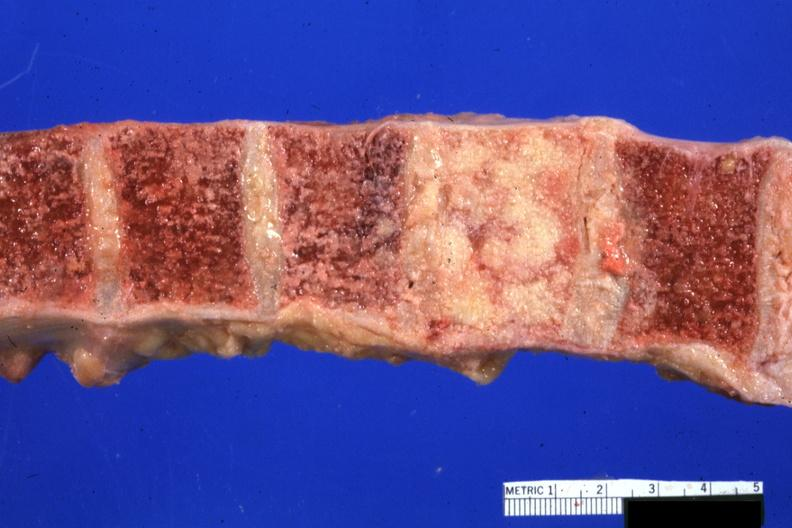how is vertebral bodies with one replaced replaced by neoplasm photo 68yowm cord compression?
Answer the question using a single word or phrase. Excellent 